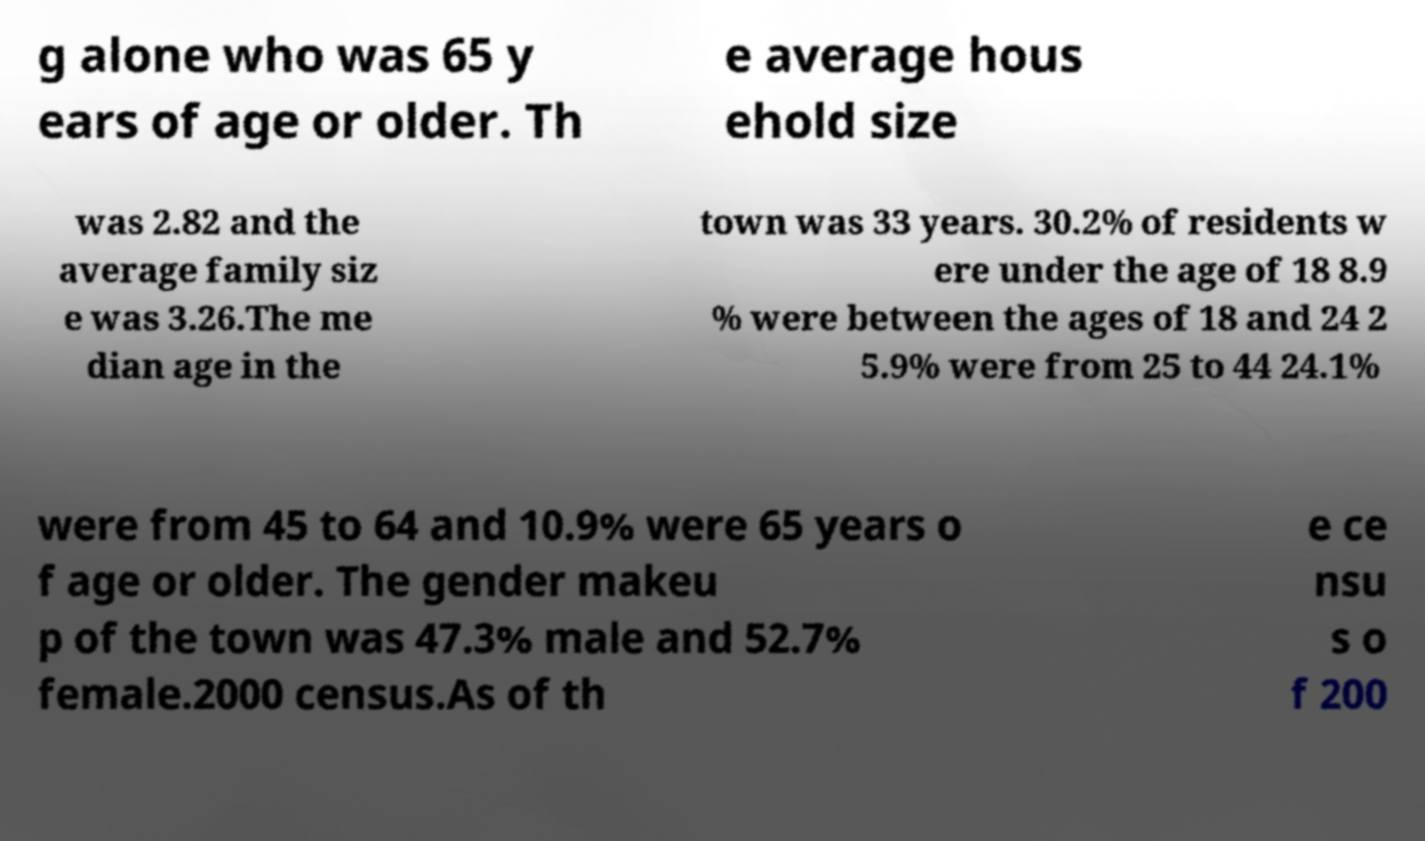What messages or text are displayed in this image? I need them in a readable, typed format. g alone who was 65 y ears of age or older. Th e average hous ehold size was 2.82 and the average family siz e was 3.26.The me dian age in the town was 33 years. 30.2% of residents w ere under the age of 18 8.9 % were between the ages of 18 and 24 2 5.9% were from 25 to 44 24.1% were from 45 to 64 and 10.9% were 65 years o f age or older. The gender makeu p of the town was 47.3% male and 52.7% female.2000 census.As of th e ce nsu s o f 200 